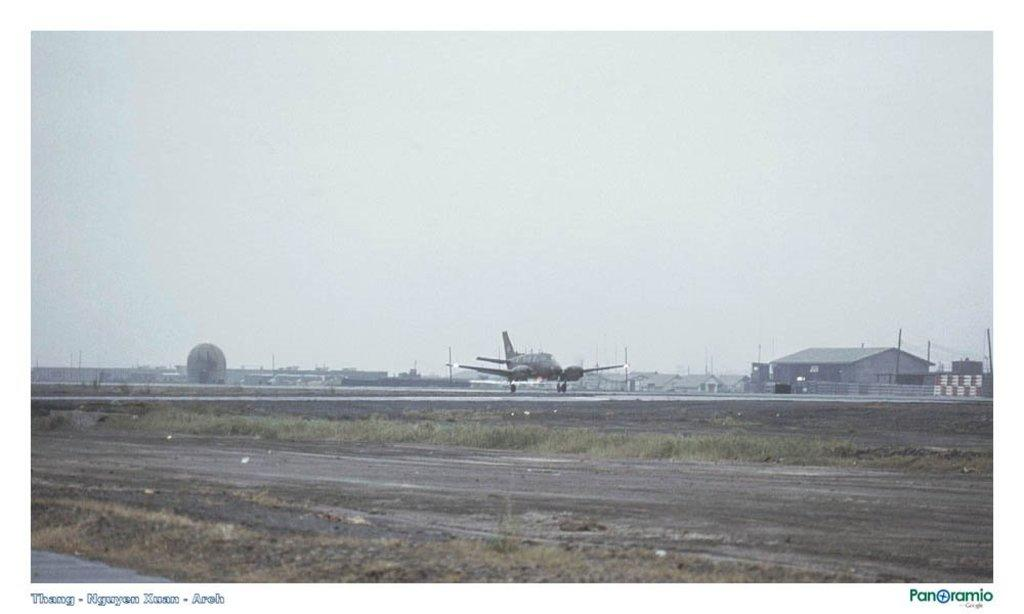What is the main subject in the center of the image? There is an aeroplane on the runway in the center of the image. What can be seen at the bottom of the image? There is a road and grass at the bottom of the image. What is visible in the background of the image? There are buildings, poles, and the sky visible in the background of the image. Can you tell me who won the competition depicted in the image? There is no competition present in the image; it features an aeroplane on a runway, a road, grass, buildings, poles, and the sky. What type of beast can be seen giving birth in the image? There is no beast or any birth-related activity depicted in the image. 